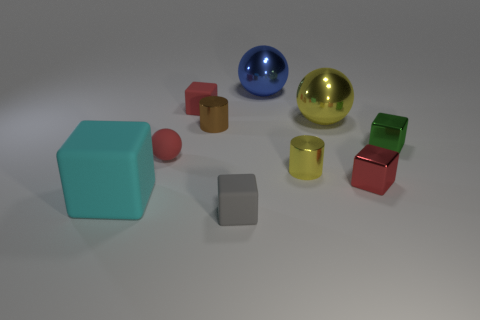Subtract 2 cubes. How many cubes are left? 3 Subtract all small gray rubber blocks. How many blocks are left? 4 Subtract all balls. How many objects are left? 7 Subtract all big purple metallic cylinders. Subtract all green shiny things. How many objects are left? 9 Add 2 big cyan things. How many big cyan things are left? 3 Add 9 big blue cylinders. How many big blue cylinders exist? 9 Subtract 1 gray blocks. How many objects are left? 9 